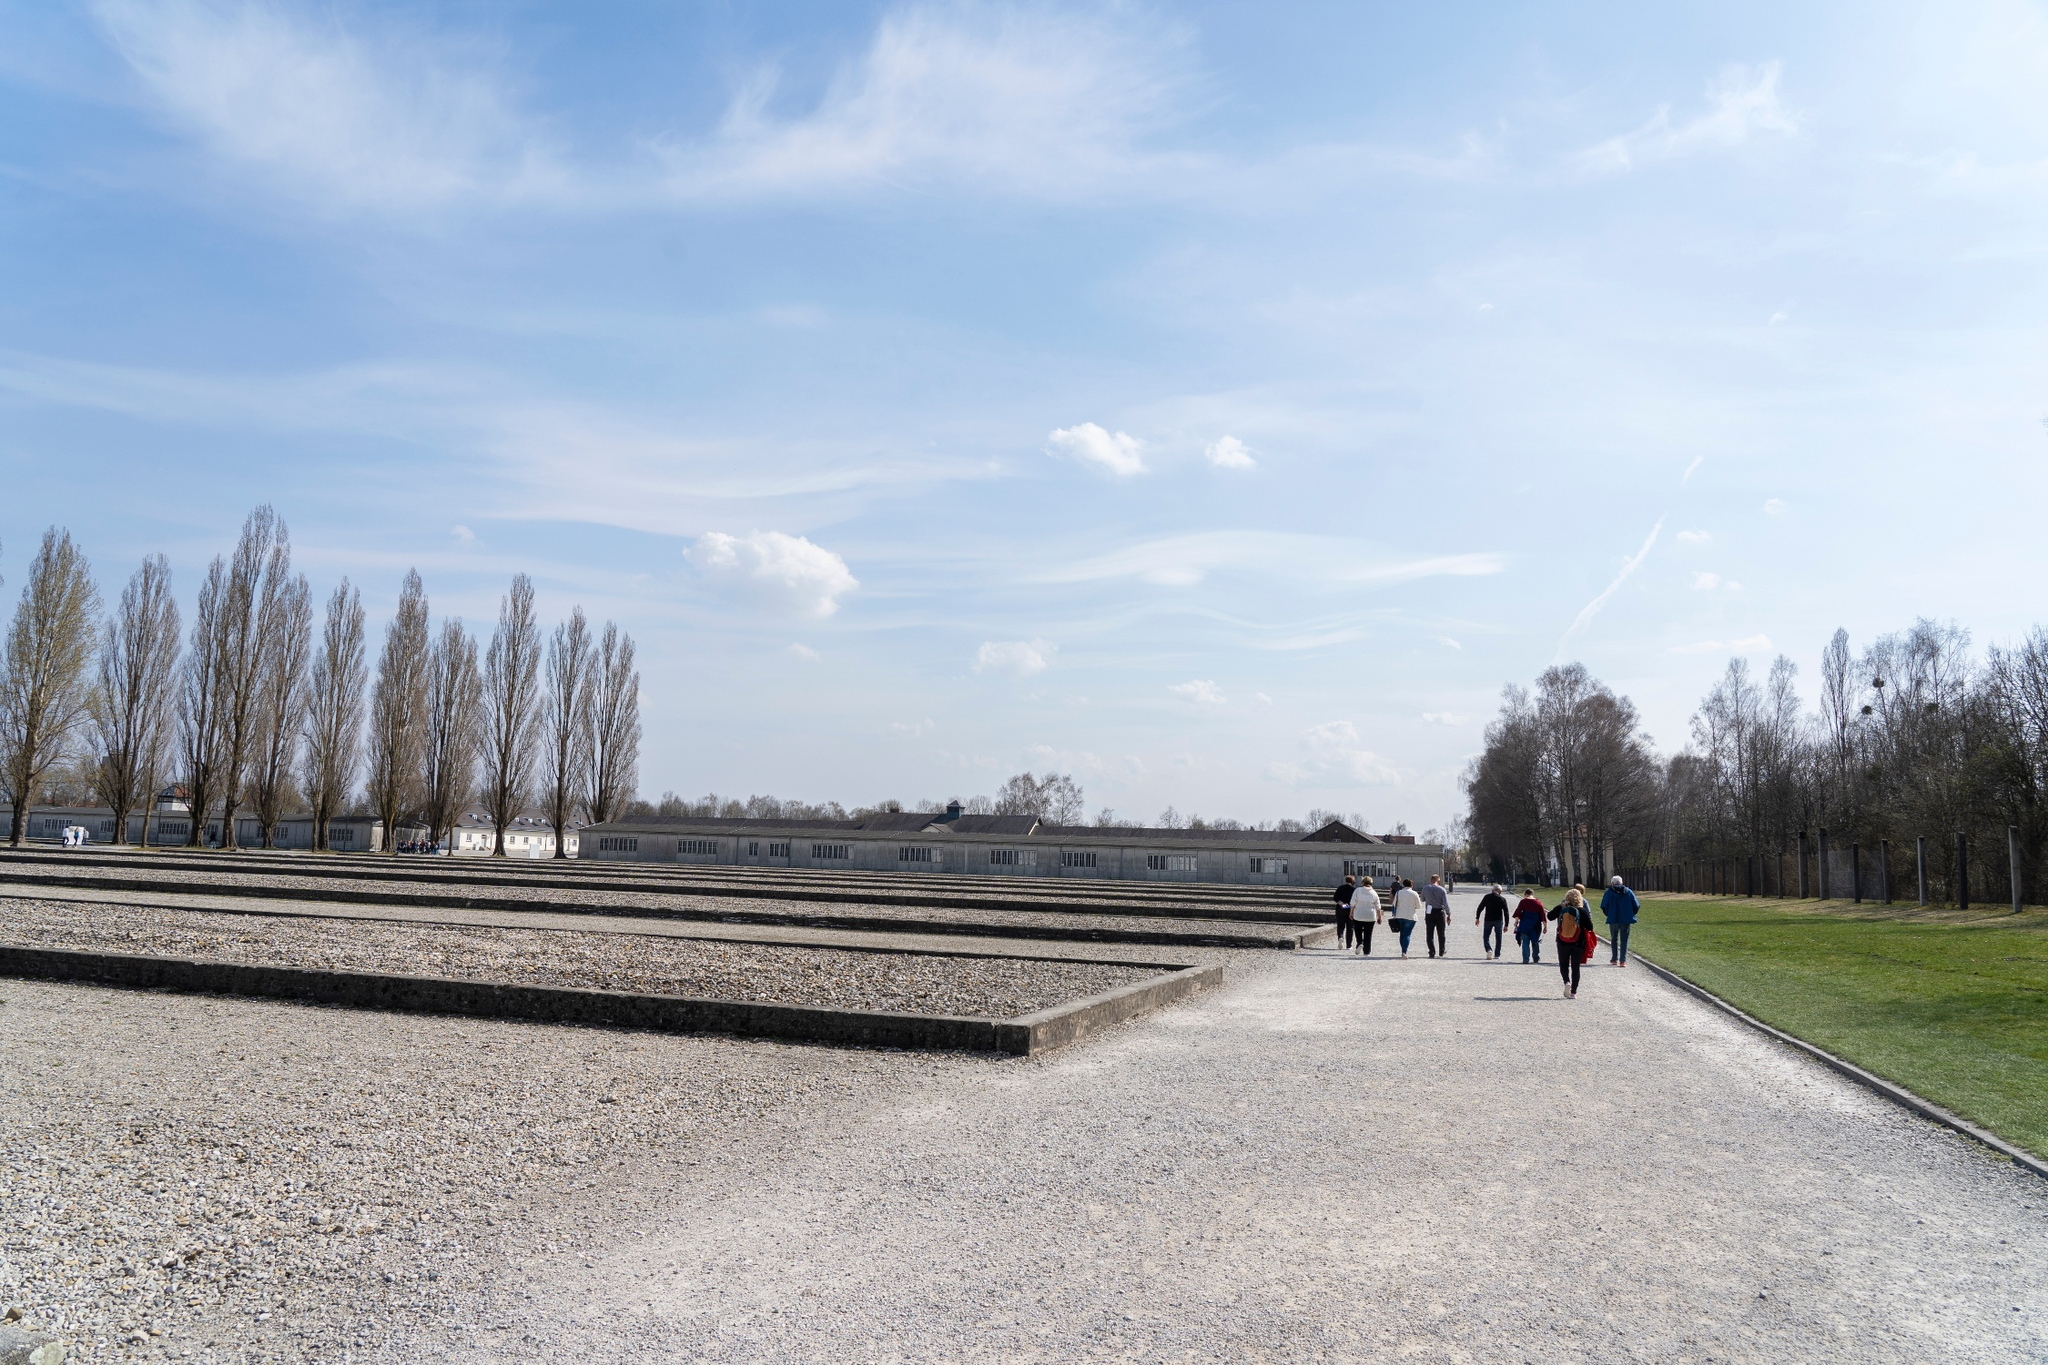Can you write a creative story inspired by this image? As the sun rose over the Dachau Memorial Site, the shadows of history mingled with the morning light, casting a contemplative aura over the graves and pathways. Among the visitors walking that day was Anna, a history student, carrying with her an old sepia-toned photograph of her great-grandfather. The photograph showed a young soldier, not much older than she, standing rigidly in a uniform that bore the marks of a time long past. Guided by stories passed down through her family, Anna traveled to Dachau to trace her great-grandfather’s footsteps, to understand the man behind the solemn eyes in the photograph. As she walked along the gravel path, she imagined her great-grandfather's thoughts, the fears he might have faced, and the hope he would have clung to. She felt a connection to the place, not just through history, but through the lineage of her family’s resilience and survival. The trees, stripped bare, seemed to echo with silent testimonies, and she felt a profound sense of purpose as she quietly vowed to honor their stories by never letting their memories fade. 